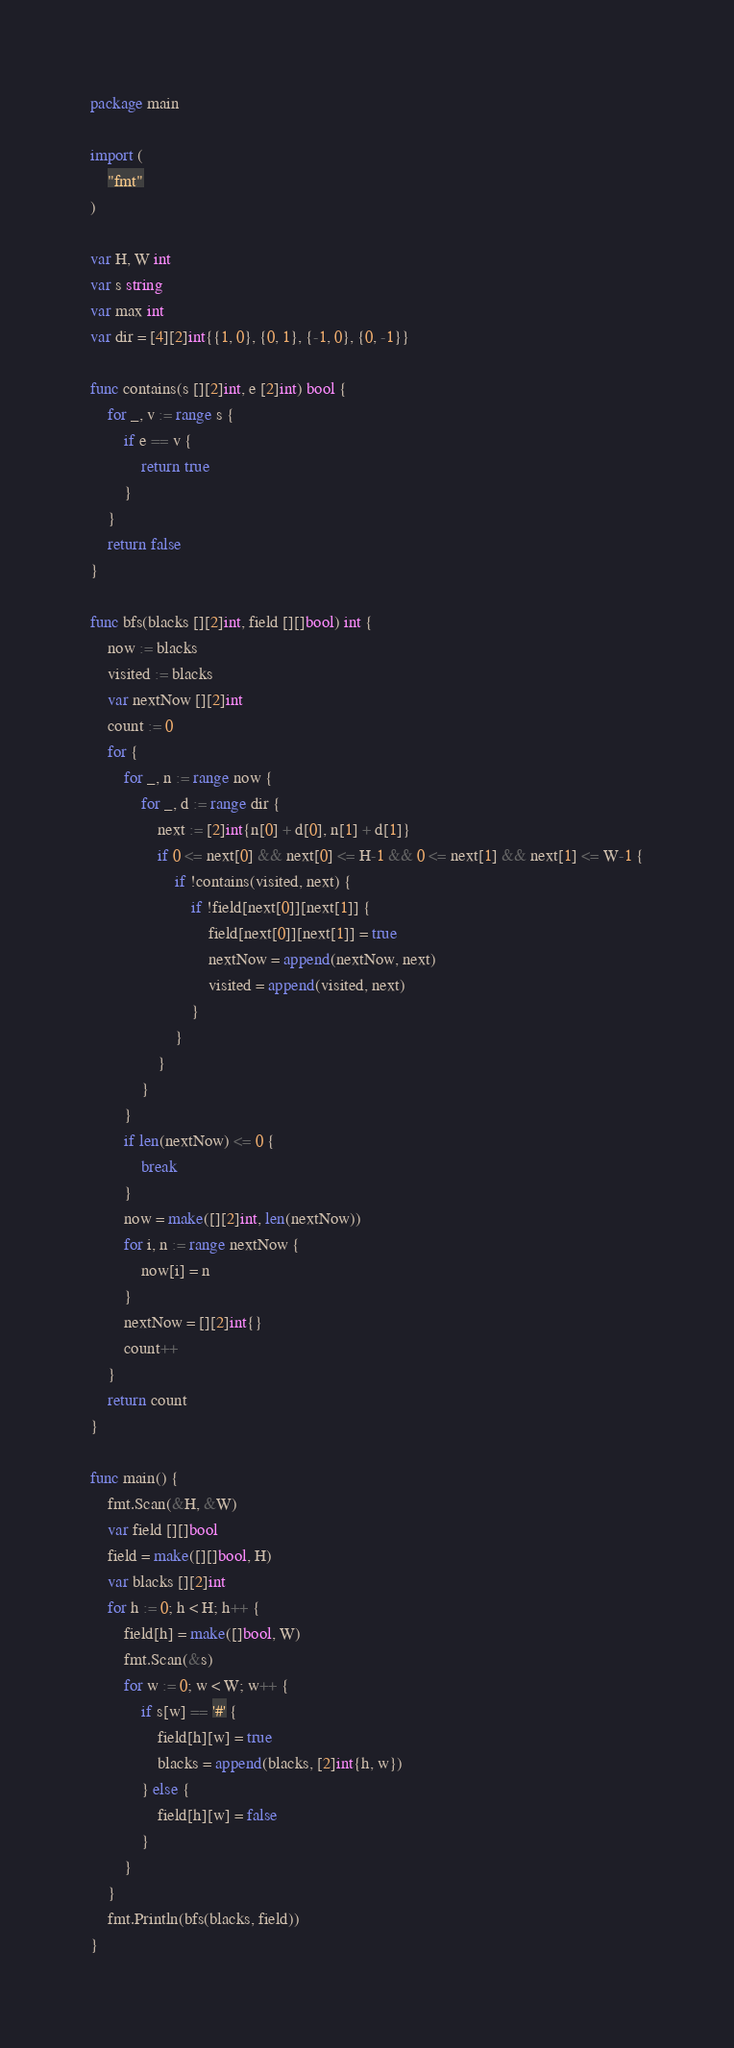<code> <loc_0><loc_0><loc_500><loc_500><_Go_>package main

import (
	"fmt"
)

var H, W int
var s string
var max int
var dir = [4][2]int{{1, 0}, {0, 1}, {-1, 0}, {0, -1}}

func contains(s [][2]int, e [2]int) bool {
	for _, v := range s {
		if e == v {
			return true
		}
	}
	return false
}

func bfs(blacks [][2]int, field [][]bool) int {
	now := blacks
	visited := blacks
	var nextNow [][2]int
	count := 0
	for {
		for _, n := range now {
			for _, d := range dir {
				next := [2]int{n[0] + d[0], n[1] + d[1]}
				if 0 <= next[0] && next[0] <= H-1 && 0 <= next[1] && next[1] <= W-1 {
					if !contains(visited, next) {
						if !field[next[0]][next[1]] {
							field[next[0]][next[1]] = true
							nextNow = append(nextNow, next)
							visited = append(visited, next)
						}
					}
				}
			}
		}
		if len(nextNow) <= 0 {
			break
		}
		now = make([][2]int, len(nextNow))
		for i, n := range nextNow {
			now[i] = n
		}
		nextNow = [][2]int{}
		count++
	}
	return count
}

func main() {
	fmt.Scan(&H, &W)
	var field [][]bool
	field = make([][]bool, H)
	var blacks [][2]int
	for h := 0; h < H; h++ {
		field[h] = make([]bool, W)
		fmt.Scan(&s)
		for w := 0; w < W; w++ {
			if s[w] == '#' {
				field[h][w] = true
				blacks = append(blacks, [2]int{h, w})
			} else {
				field[h][w] = false
			}
		}
	}
	fmt.Println(bfs(blacks, field))
}
</code> 